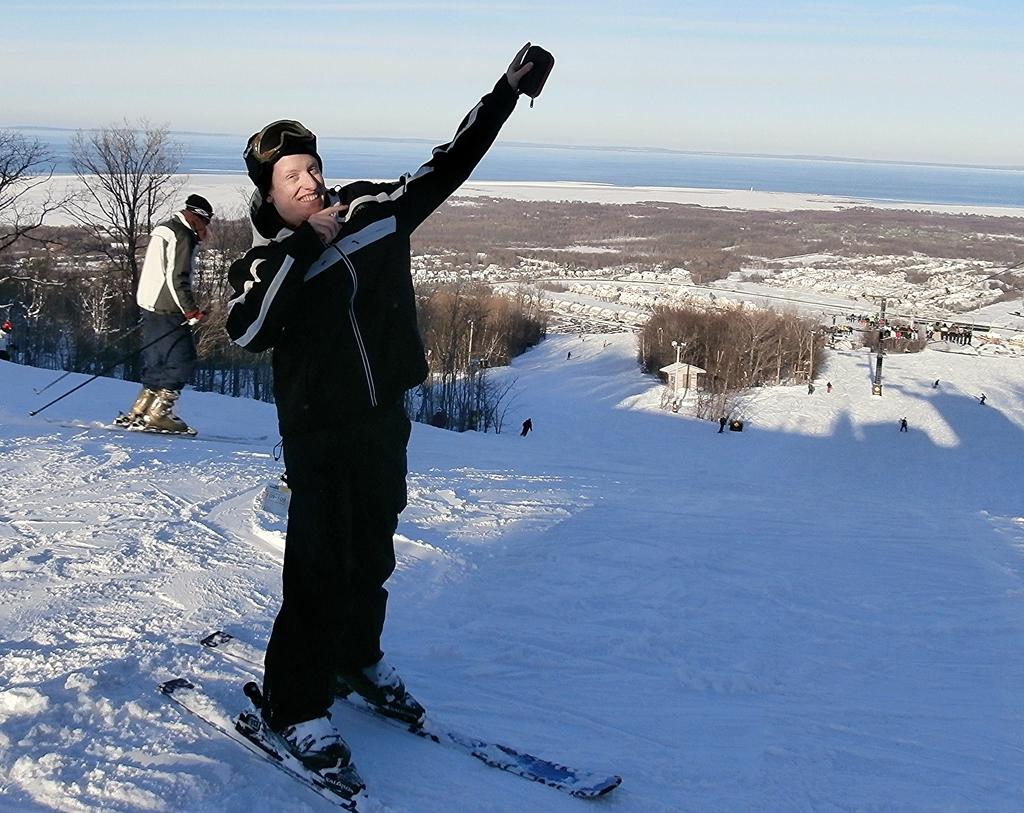What is the main subject in the center of the image? There is a person with a ski board in the center of the image. What is the surface the person is standing on? The person is on the snow. Can you describe the background of the image? In the background, there is another person skiing, trees, other persons, a pole, water, and the sky are visible. What type of bean is being used as a prop in the image? There is no bean present in the image; it features a person with a ski board on the snow, with various elements visible in the background. 